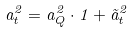<formula> <loc_0><loc_0><loc_500><loc_500>a _ { t } ^ { 2 } = a _ { Q } ^ { 2 } \cdot { 1 } + \tilde { a } _ { t } ^ { 2 }</formula> 